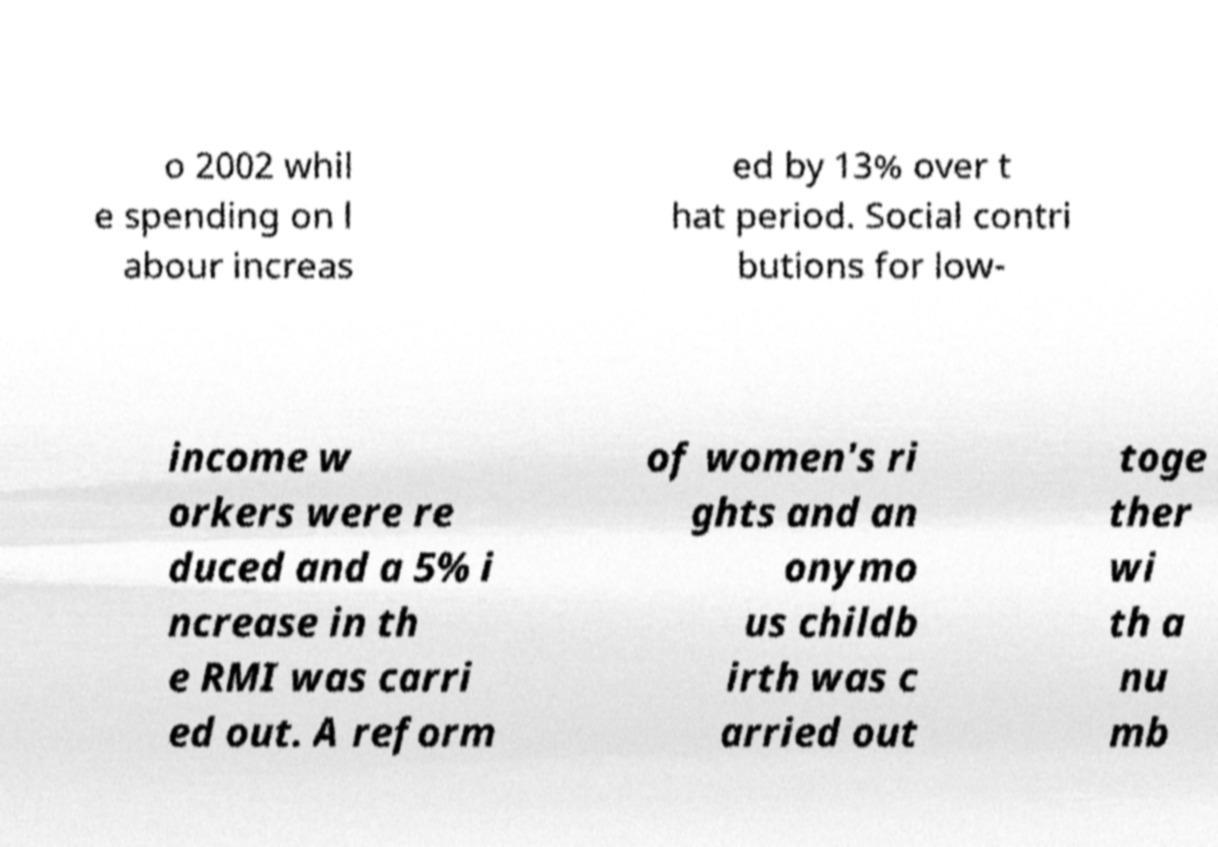I need the written content from this picture converted into text. Can you do that? o 2002 whil e spending on l abour increas ed by 13% over t hat period. Social contri butions for low- income w orkers were re duced and a 5% i ncrease in th e RMI was carri ed out. A reform of women's ri ghts and an onymo us childb irth was c arried out toge ther wi th a nu mb 